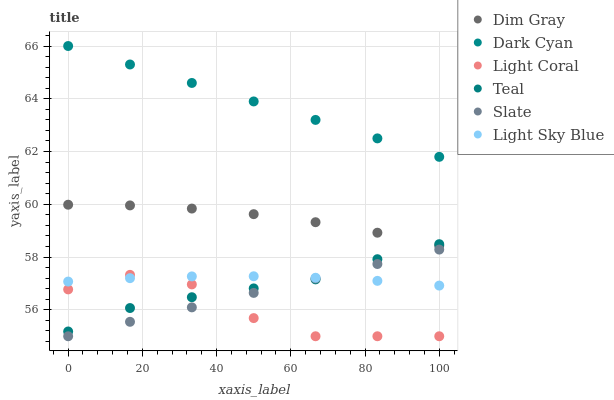Does Light Coral have the minimum area under the curve?
Answer yes or no. Yes. Does Dark Cyan have the maximum area under the curve?
Answer yes or no. Yes. Does Slate have the minimum area under the curve?
Answer yes or no. No. Does Slate have the maximum area under the curve?
Answer yes or no. No. Is Dark Cyan the smoothest?
Answer yes or no. Yes. Is Light Coral the roughest?
Answer yes or no. Yes. Is Slate the smoothest?
Answer yes or no. No. Is Slate the roughest?
Answer yes or no. No. Does Slate have the lowest value?
Answer yes or no. Yes. Does Light Sky Blue have the lowest value?
Answer yes or no. No. Does Dark Cyan have the highest value?
Answer yes or no. Yes. Does Slate have the highest value?
Answer yes or no. No. Is Teal less than Dark Cyan?
Answer yes or no. Yes. Is Dark Cyan greater than Teal?
Answer yes or no. Yes. Does Light Sky Blue intersect Slate?
Answer yes or no. Yes. Is Light Sky Blue less than Slate?
Answer yes or no. No. Is Light Sky Blue greater than Slate?
Answer yes or no. No. Does Teal intersect Dark Cyan?
Answer yes or no. No. 